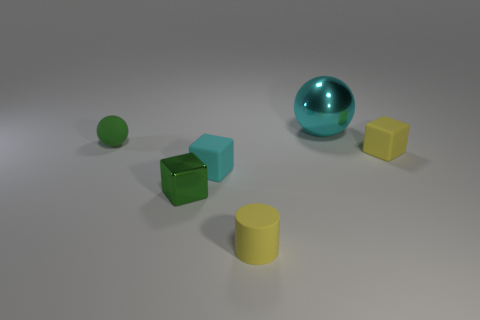What number of large cyan balls are on the right side of the shiny object to the right of the yellow matte cylinder?
Keep it short and to the point. 0. What material is the cyan thing that is the same size as the green cube?
Provide a succinct answer. Rubber. How many other objects are there of the same material as the green cube?
Ensure brevity in your answer.  1. There is a small green metal thing; what number of metallic things are behind it?
Your answer should be compact. 1. How many spheres are either small green matte things or big cyan metal objects?
Give a very brief answer. 2. There is a object that is in front of the cyan matte object and right of the small cyan block; what size is it?
Keep it short and to the point. Small. How many other things are there of the same color as the large object?
Give a very brief answer. 1. Are the green block and the tiny yellow object that is behind the small metallic object made of the same material?
Ensure brevity in your answer.  No. What number of things are yellow things behind the green shiny thing or green rubber things?
Make the answer very short. 2. What is the shape of the object that is both on the right side of the small cylinder and in front of the shiny sphere?
Your answer should be very brief. Cube. 